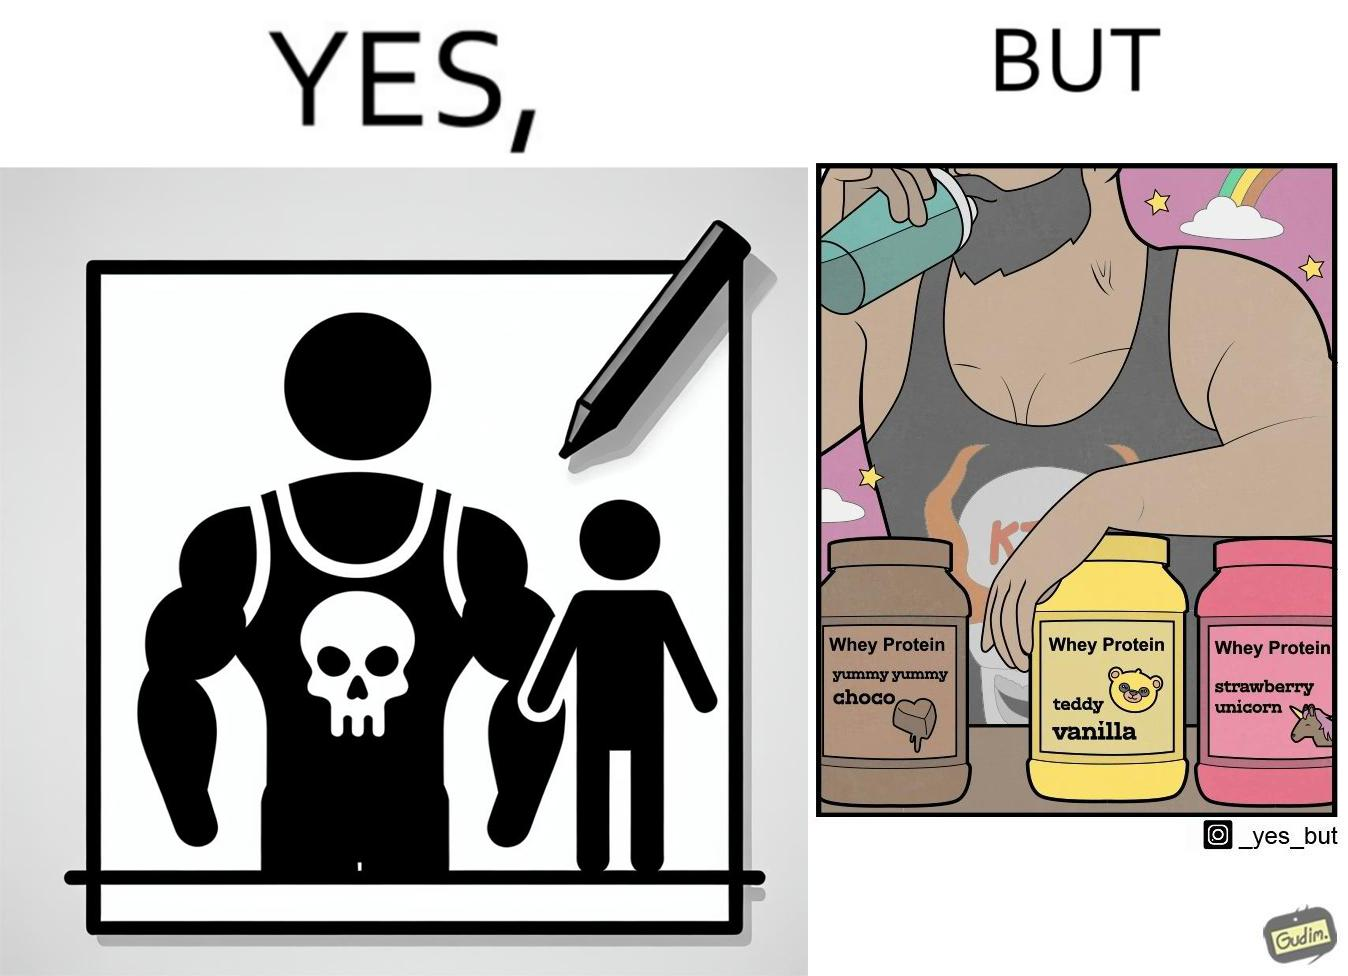Is this image satirical or non-satirical? Yes, this image is satirical. 